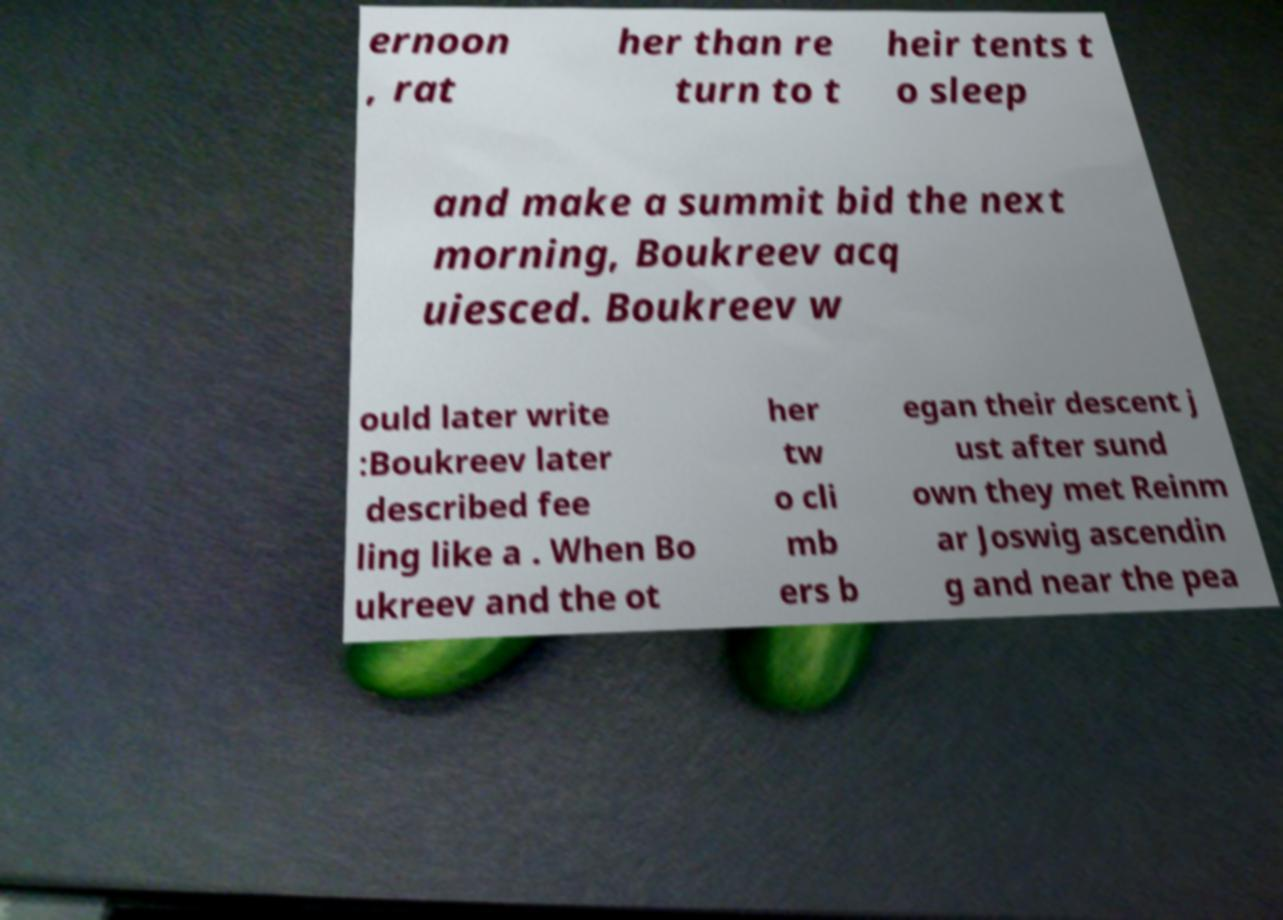Could you extract and type out the text from this image? ernoon , rat her than re turn to t heir tents t o sleep and make a summit bid the next morning, Boukreev acq uiesced. Boukreev w ould later write :Boukreev later described fee ling like a . When Bo ukreev and the ot her tw o cli mb ers b egan their descent j ust after sund own they met Reinm ar Joswig ascendin g and near the pea 